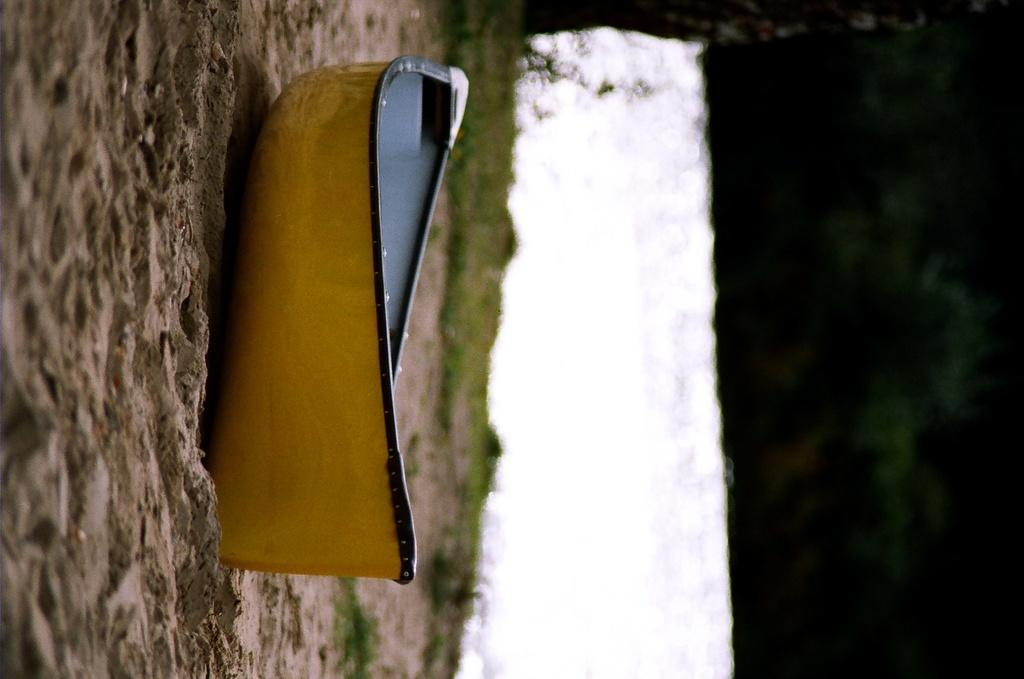What is the main subject of the image? There is a boat in the image. What color is the boat? The boat is yellow in color. Where is the boat located in the image? The boat is on the ground. What type of terrain can be seen in the image? There is sand in the image. How would you describe the background of the image? The background of the image is blurry. What type of picture is hanging on the wall in the image? There is no mention of a picture hanging on the wall in the image; the focus is on the boat and its surroundings. 